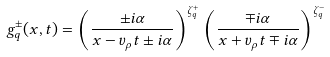<formula> <loc_0><loc_0><loc_500><loc_500>g _ { q } ^ { \pm } ( x , t ) = \left ( \frac { \pm i \alpha } { x - v _ { \rho } t \pm i \alpha } \right ) ^ { \zeta ^ { + } _ { q } } \left ( \frac { \mp i \alpha } { x + v _ { \rho } t \mp i \alpha } \right ) ^ { \zeta ^ { - } _ { q } }</formula> 